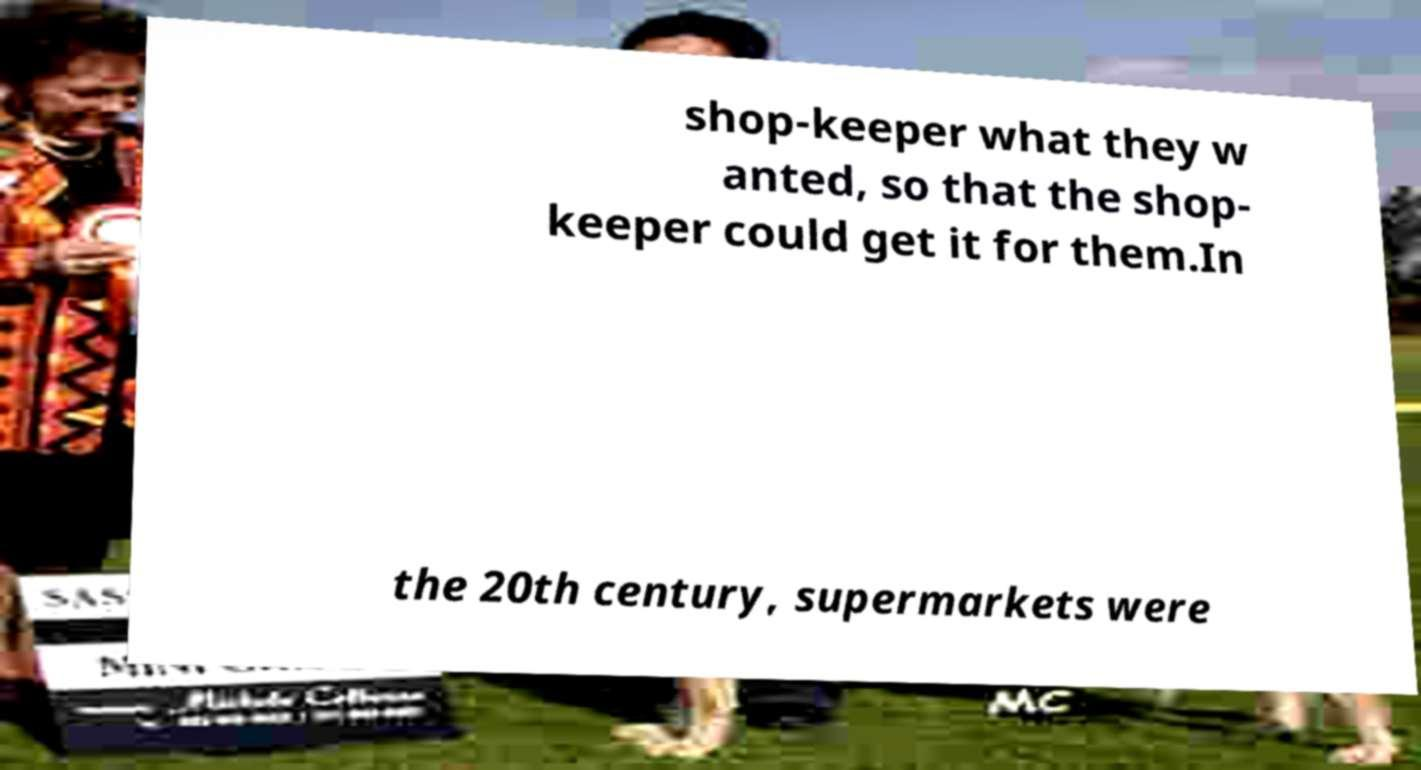Could you assist in decoding the text presented in this image and type it out clearly? shop-keeper what they w anted, so that the shop- keeper could get it for them.In the 20th century, supermarkets were 